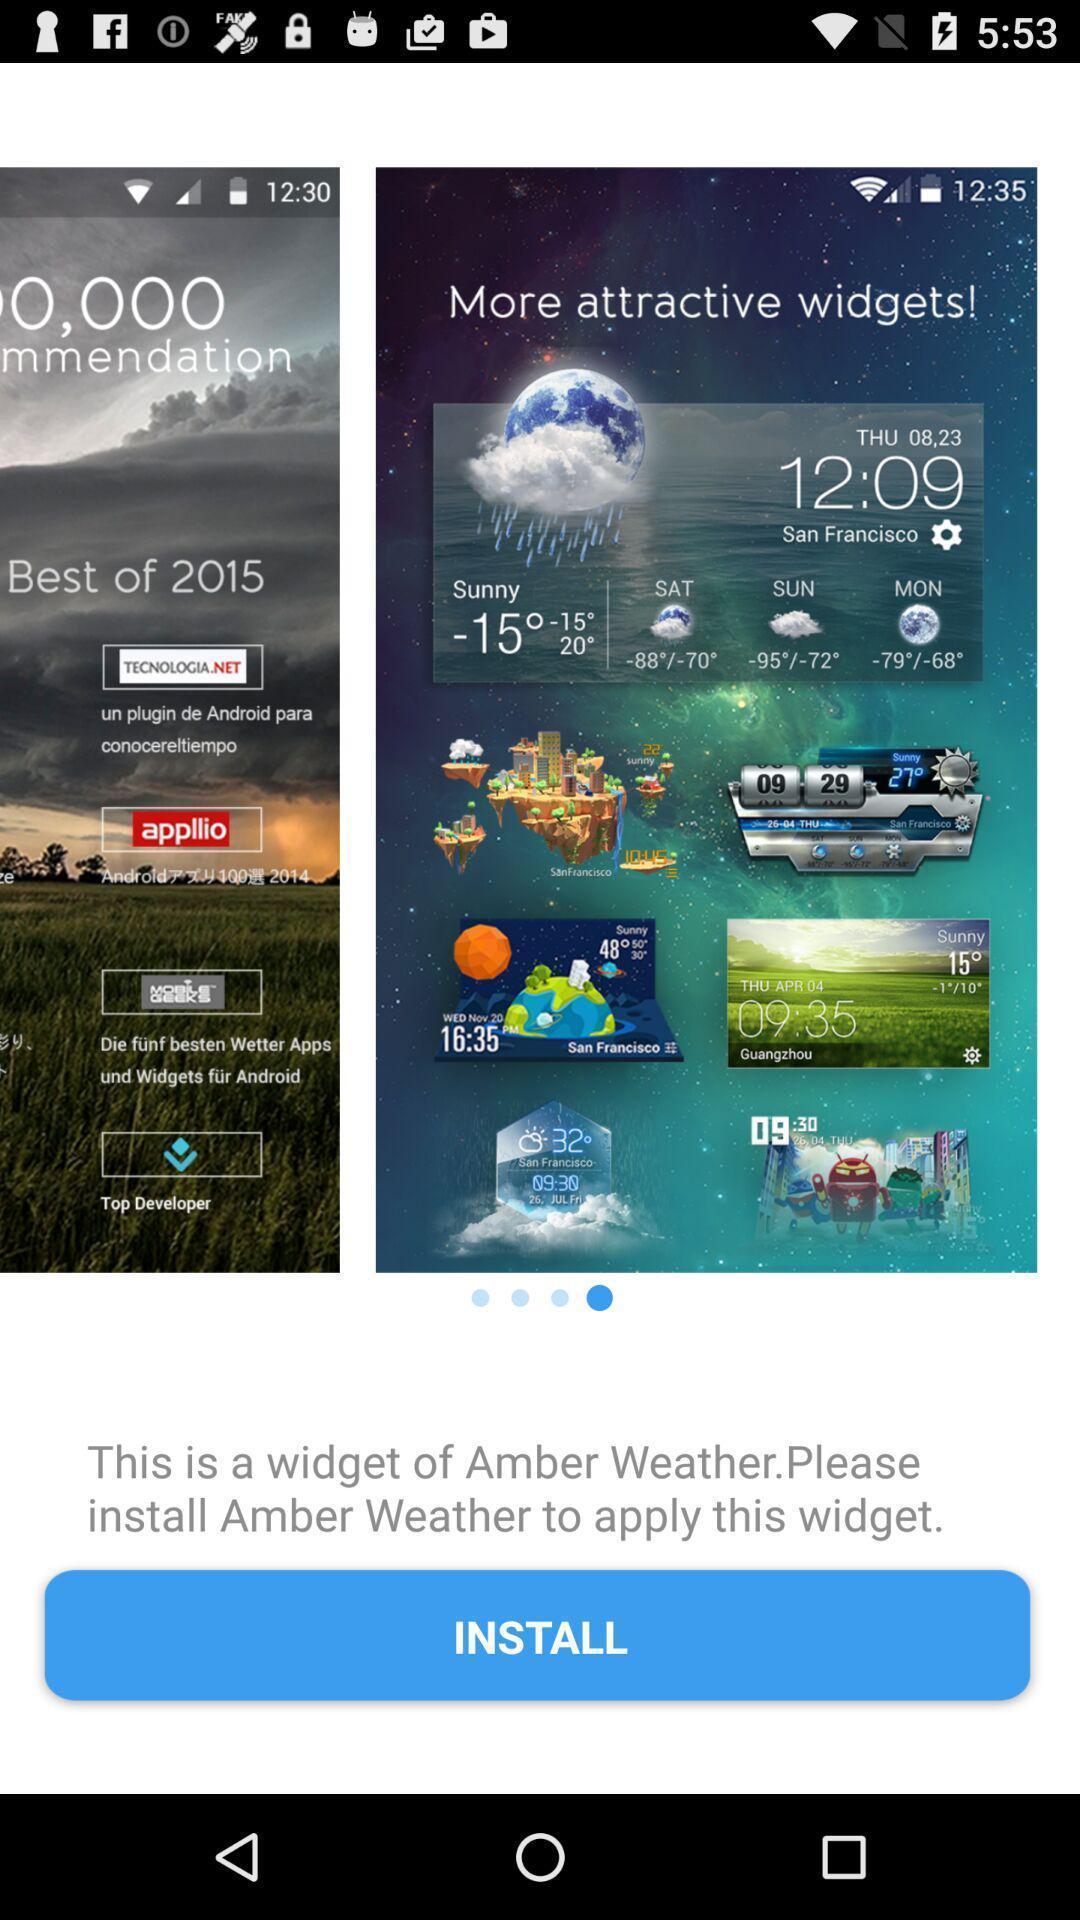Tell me what you see in this picture. Page to install an application. 